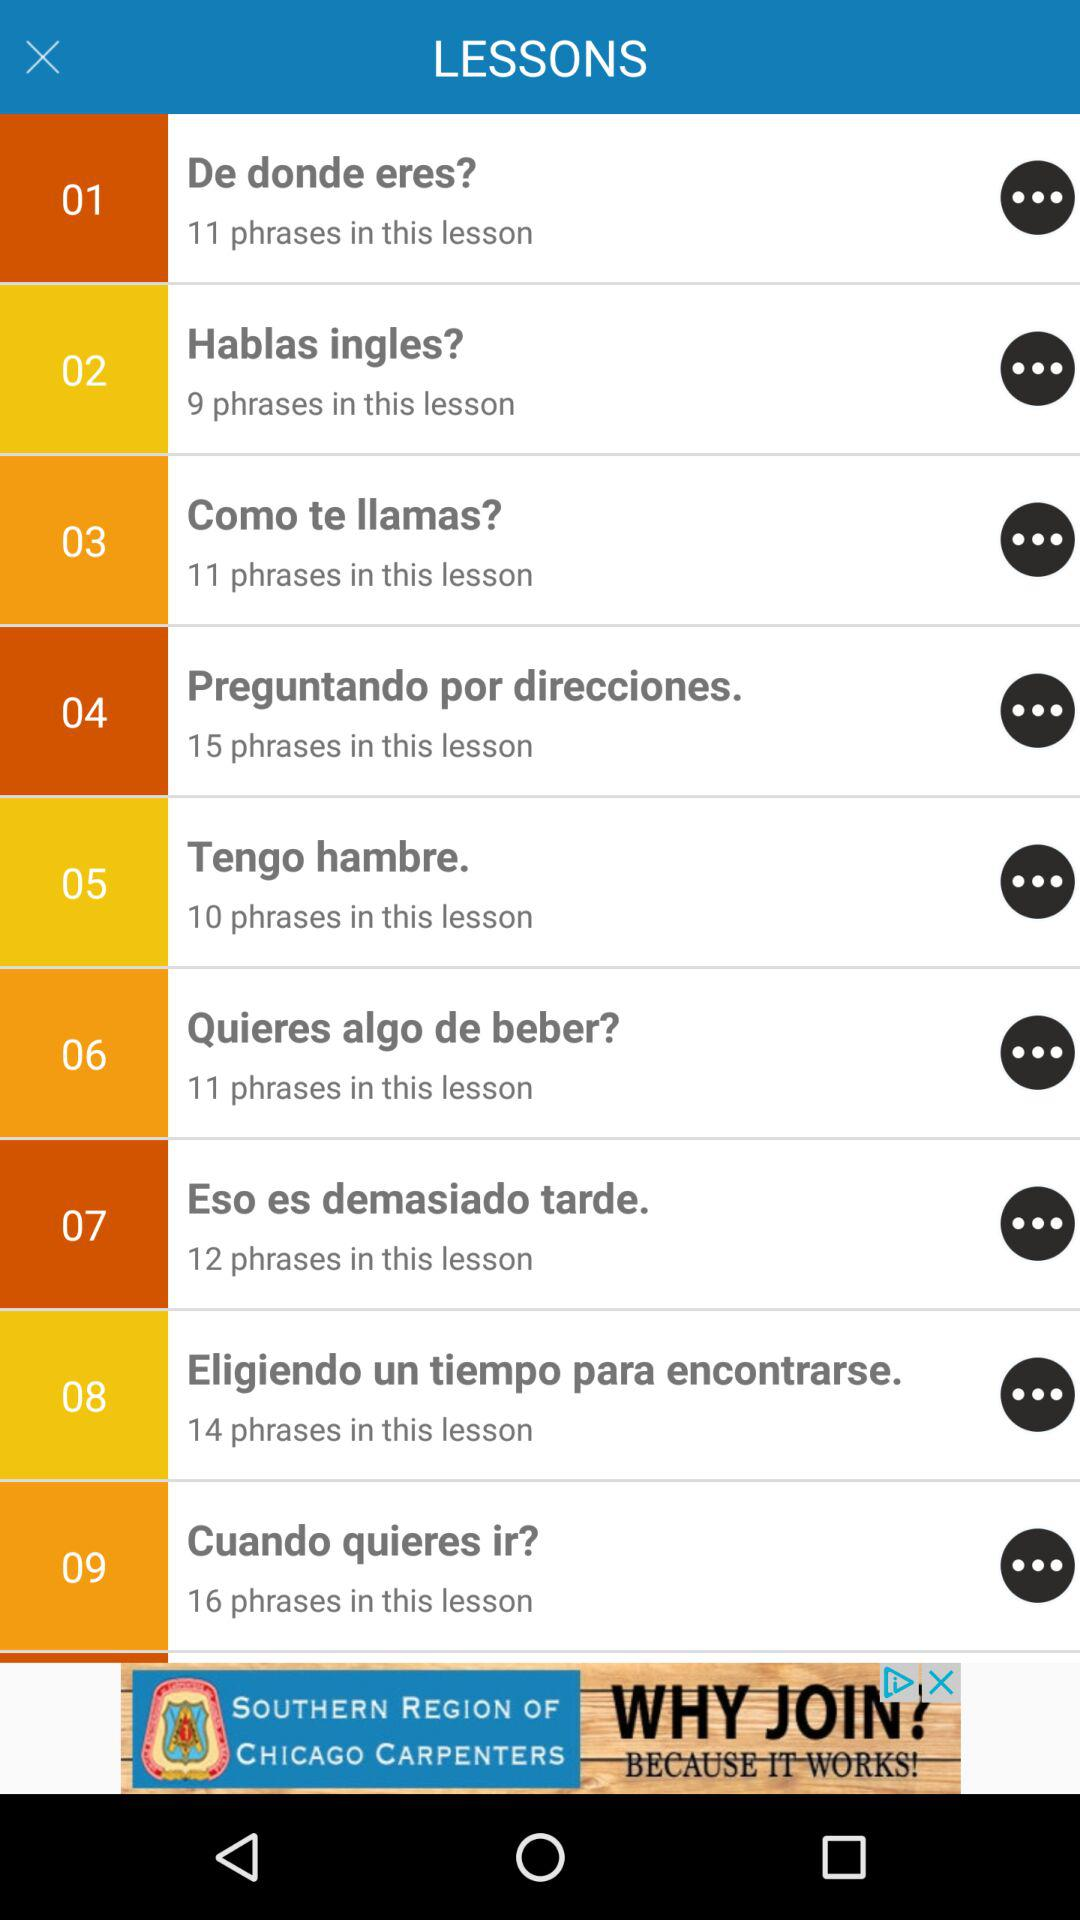How many phrases are in the lesson titled 'De donde eres?'
Answer the question using a single word or phrase. 11 